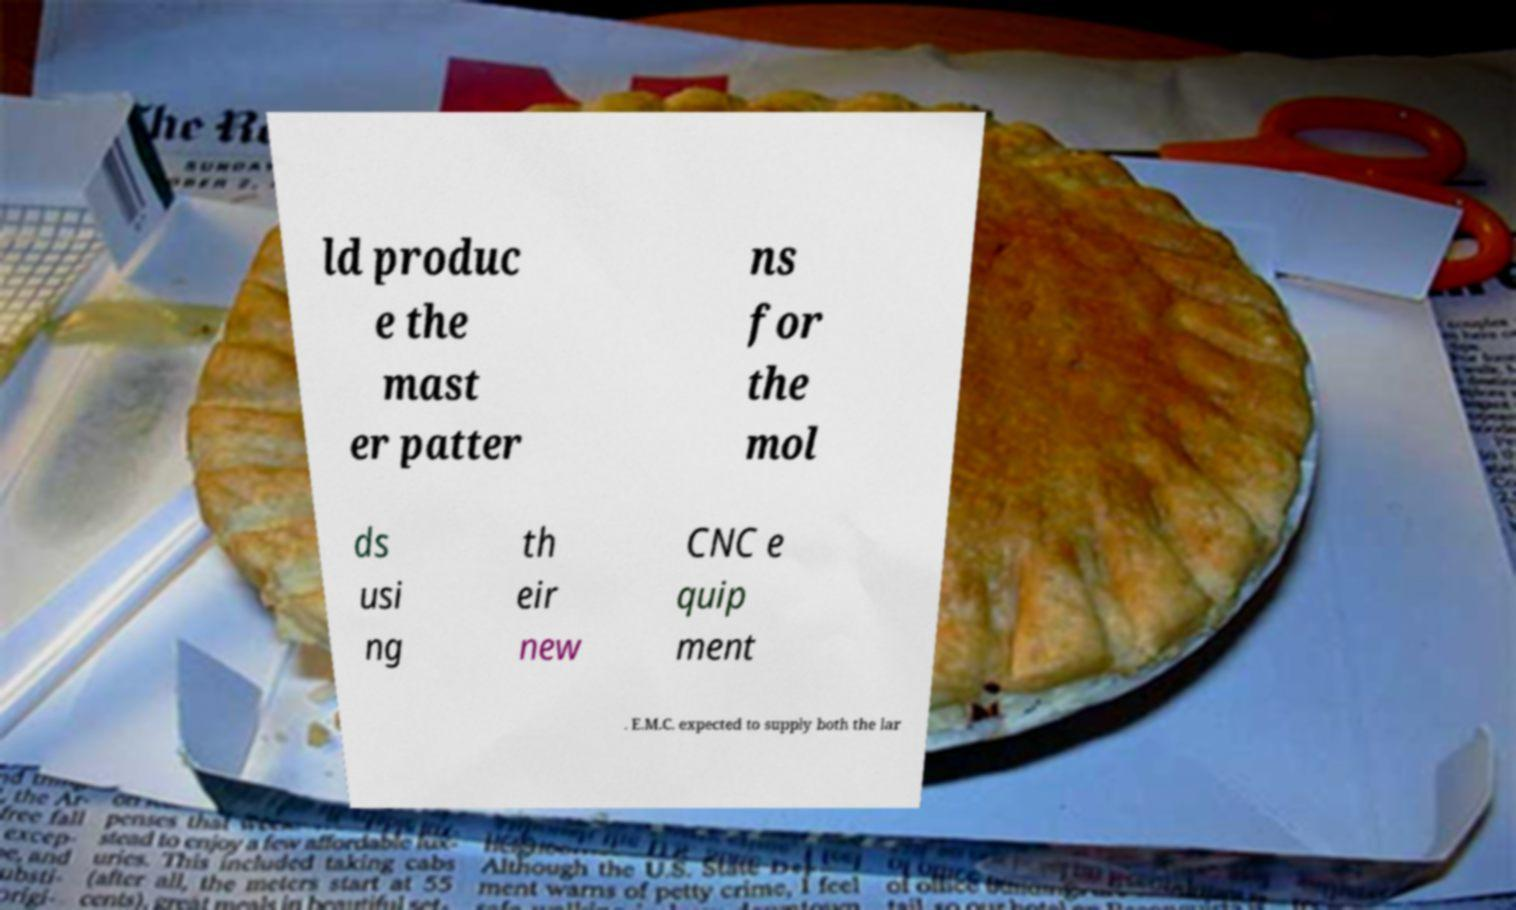What messages or text are displayed in this image? I need them in a readable, typed format. ld produc e the mast er patter ns for the mol ds usi ng th eir new CNC e quip ment . E.M.C. expected to supply both the lar 